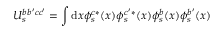Convert formula to latex. <formula><loc_0><loc_0><loc_500><loc_500>U _ { s } ^ { b b ^ { \prime } c c ^ { \prime } } = \int d x \phi _ { s } ^ { c * } ( x ) \phi _ { s } ^ { c ^ { \prime } * } ( x ) \phi _ { s } ^ { b } ( x ) \phi _ { s } ^ { b ^ { \prime } } ( x )</formula> 